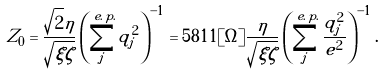Convert formula to latex. <formula><loc_0><loc_0><loc_500><loc_500>Z _ { 0 } = \frac { \sqrt { 2 } \eta } { \sqrt { \xi \zeta } } \left ( \sum _ { j } ^ { e . \, p . } q _ { j } ^ { 2 } \right ) ^ { - 1 } = 5 8 1 1 [ \Omega ] \frac { \eta } { \sqrt { \xi \zeta } } \left ( \sum _ { j } ^ { e . \, p . } \frac { q _ { j } ^ { 2 } } { e ^ { 2 } } \right ) ^ { - 1 } .</formula> 